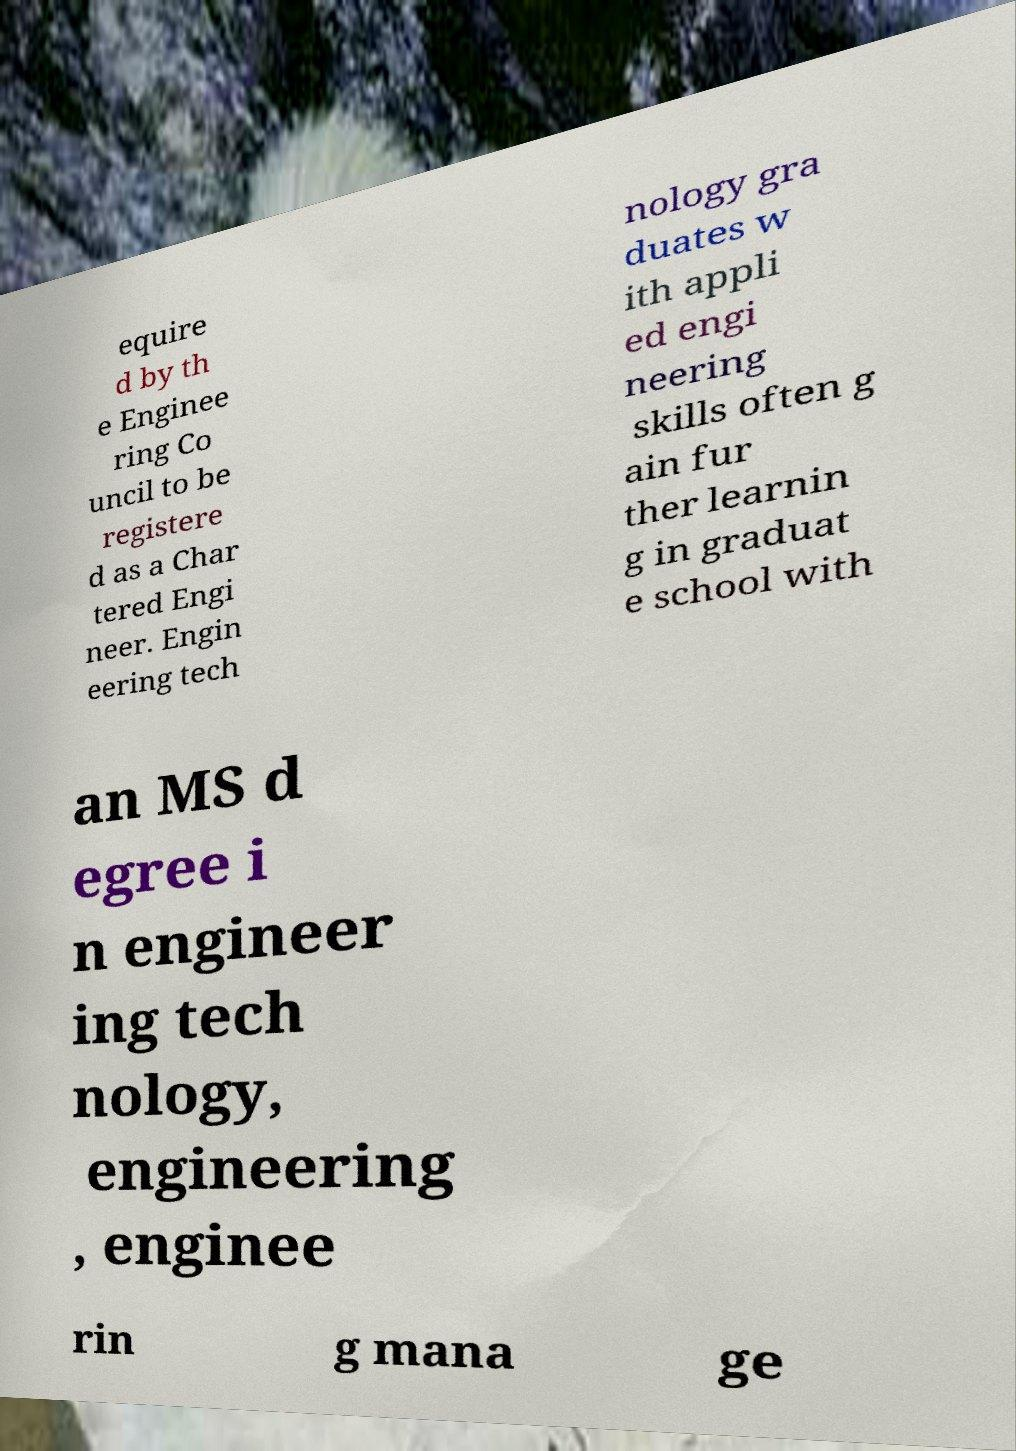Please identify and transcribe the text found in this image. equire d by th e Enginee ring Co uncil to be registere d as a Char tered Engi neer. Engin eering tech nology gra duates w ith appli ed engi neering skills often g ain fur ther learnin g in graduat e school with an MS d egree i n engineer ing tech nology, engineering , enginee rin g mana ge 